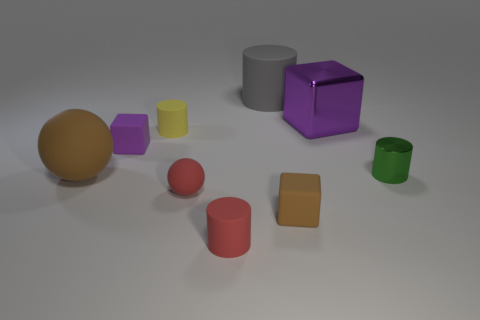Are there more cubes behind the tiny green shiny thing than tiny cyan matte cylinders?
Ensure brevity in your answer.  Yes. There is a tiny rubber thing that is the same color as the large ball; what is its shape?
Provide a short and direct response. Cube. Is there a small purple block that has the same material as the brown ball?
Provide a succinct answer. Yes. Does the purple thing in front of the large purple metallic thing have the same material as the cube in front of the green metallic cylinder?
Your answer should be compact. Yes. Is the number of cubes that are behind the tiny purple block the same as the number of tiny rubber cylinders that are behind the small green thing?
Keep it short and to the point. Yes. There is a cube that is the same size as the brown rubber sphere; what color is it?
Your response must be concise. Purple. Are there any tiny rubber things that have the same color as the big block?
Your answer should be compact. Yes. How many objects are rubber things right of the big sphere or small green matte spheres?
Give a very brief answer. 6. How many other things are the same size as the purple metallic thing?
Give a very brief answer. 2. What material is the small cylinder to the right of the purple thing that is right of the matte cylinder behind the large metal block made of?
Your answer should be very brief. Metal. 